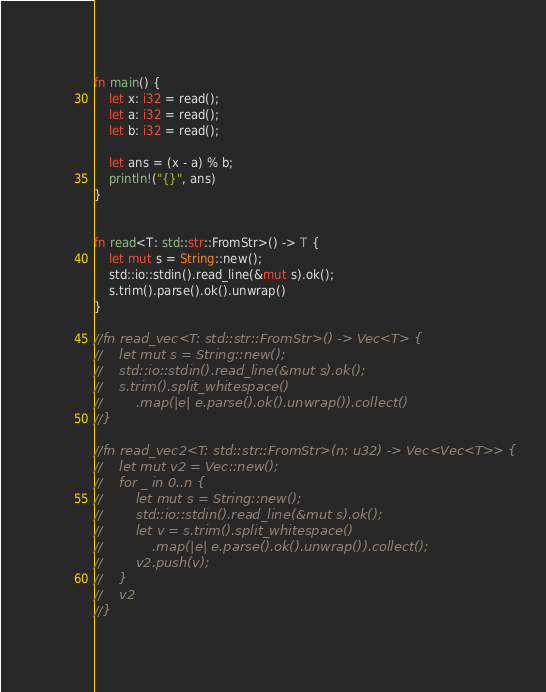<code> <loc_0><loc_0><loc_500><loc_500><_Rust_>fn main() {
    let x: i32 = read();
    let a: i32 = read();
    let b: i32 = read();

    let ans = (x - a) % b;
    println!("{}", ans)
}


fn read<T: std::str::FromStr>() -> T {
    let mut s = String::new();
    std::io::stdin().read_line(&mut s).ok();
    s.trim().parse().ok().unwrap()
}

//fn read_vec<T: std::str::FromStr>() -> Vec<T> {
//    let mut s = String::new();
//    std::io::stdin().read_line(&mut s).ok();
//    s.trim().split_whitespace()
//        .map(|e| e.parse().ok().unwrap()).collect()
//}

//fn read_vec2<T: std::str::FromStr>(n: u32) -> Vec<Vec<T>> {
//    let mut v2 = Vec::new();
//    for _ in 0..n {
//        let mut s = String::new();
//        std::io::stdin().read_line(&mut s).ok();
//        let v = s.trim().split_whitespace()
//            .map(|e| e.parse().ok().unwrap()).collect();
//        v2.push(v);
//    }
//    v2
//}</code> 